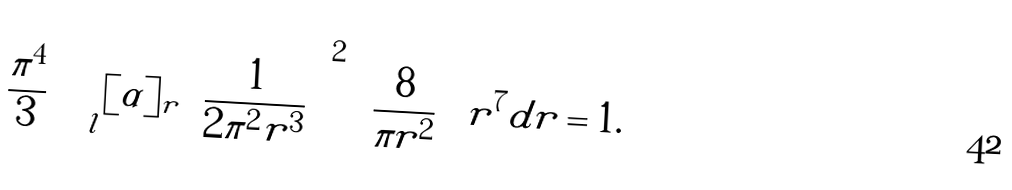<formula> <loc_0><loc_0><loc_500><loc_500>\frac { \pi ^ { 4 } } { 3 } \int _ { l } [ \alpha ] _ { r } \left ( \frac { 1 } { 2 \pi ^ { 2 } r ^ { 3 } } \right ) ^ { 2 } \left ( \frac { 8 } { \pi r ^ { 2 } } \right ) r ^ { 7 } d r = 1 .</formula> 